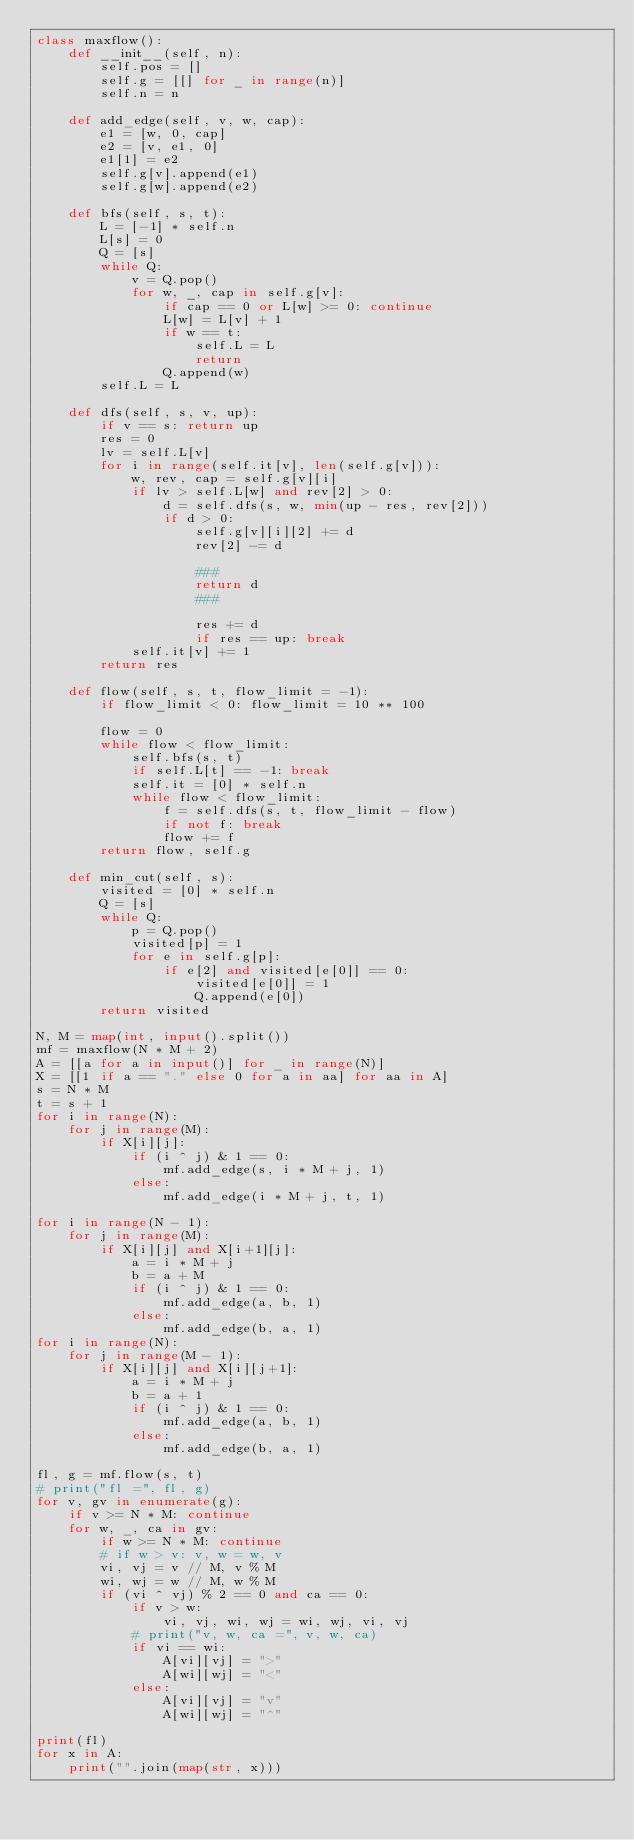Convert code to text. <code><loc_0><loc_0><loc_500><loc_500><_Python_>class maxflow():
    def __init__(self, n):
        self.pos = []
        self.g = [[] for _ in range(n)]
        self.n = n
    
    def add_edge(self, v, w, cap):
        e1 = [w, 0, cap]
        e2 = [v, e1, 0]
        e1[1] = e2
        self.g[v].append(e1)
        self.g[w].append(e2)
    
    def bfs(self, s, t):
        L = [-1] * self.n
        L[s] = 0
        Q = [s]
        while Q:
            v = Q.pop()
            for w, _, cap in self.g[v]:
                if cap == 0 or L[w] >= 0: continue
                L[w] = L[v] + 1
                if w == t:
                    self.L = L
                    return
                Q.append(w)
        self.L = L

    def dfs(self, s, v, up):
        if v == s: return up
        res = 0
        lv = self.L[v]
        for i in range(self.it[v], len(self.g[v])):
            w, rev, cap = self.g[v][i]
            if lv > self.L[w] and rev[2] > 0:
                d = self.dfs(s, w, min(up - res, rev[2]))
                if d > 0: 
                    self.g[v][i][2] += d
                    rev[2] -= d

                    ###
                    return d
                    ###

                    res += d
                    if res == up: break
            self.it[v] += 1
        return res
    
    def flow(self, s, t, flow_limit = -1):
        if flow_limit < 0: flow_limit = 10 ** 100
        
        flow = 0
        while flow < flow_limit:
            self.bfs(s, t)
            if self.L[t] == -1: break
            self.it = [0] * self.n
            while flow < flow_limit:
                f = self.dfs(s, t, flow_limit - flow)
                if not f: break
                flow += f
        return flow, self.g
    
    def min_cut(self, s):
        visited = [0] * self.n
        Q = [s]
        while Q:
            p = Q.pop()
            visited[p] = 1
            for e in self.g[p]:
                if e[2] and visited[e[0]] == 0:
                    visited[e[0]] = 1
                    Q.append(e[0])
        return visited

N, M = map(int, input().split())
mf = maxflow(N * M + 2)
A = [[a for a in input()] for _ in range(N)]
X = [[1 if a == "." else 0 for a in aa] for aa in A]
s = N * M
t = s + 1
for i in range(N):
    for j in range(M):
        if X[i][j]:
            if (i ^ j) & 1 == 0:
                mf.add_edge(s, i * M + j, 1)
            else:
                mf.add_edge(i * M + j, t, 1)

for i in range(N - 1):
    for j in range(M):
        if X[i][j] and X[i+1][j]:
            a = i * M + j
            b = a + M
            if (i ^ j) & 1 == 0:
                mf.add_edge(a, b, 1)
            else:
                mf.add_edge(b, a, 1)
for i in range(N):
    for j in range(M - 1):
        if X[i][j] and X[i][j+1]:
            a = i * M + j
            b = a + 1
            if (i ^ j) & 1 == 0:
                mf.add_edge(a, b, 1)
            else:
                mf.add_edge(b, a, 1)

fl, g = mf.flow(s, t)
# print("fl =", fl, g)
for v, gv in enumerate(g):
    if v >= N * M: continue
    for w, _, ca in gv:
        if w >= N * M: continue
        # if w > v: v, w = w, v
        vi, vj = v // M, v % M
        wi, wj = w // M, w % M
        if (vi ^ vj) % 2 == 0 and ca == 0:
            if v > w:
                vi, vj, wi, wj = wi, wj, vi, vj
            # print("v, w, ca =", v, w, ca)
            if vi == wi:
                A[vi][vj] = ">"
                A[wi][wj] = "<"
            else:
                A[vi][vj] = "v"
                A[wi][wj] = "^"

print(fl)
for x in A:
    print("".join(map(str, x)))
</code> 